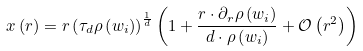<formula> <loc_0><loc_0><loc_500><loc_500>x \left ( r \right ) = r \left ( \tau _ { d } \rho \left ( w _ { i } \right ) \right ) ^ { \frac { 1 } { d } } \left ( 1 + \frac { r \cdot \partial _ { r } \rho \left ( w _ { i } \right ) } { d \cdot \rho \left ( w _ { i } \right ) } + \mathcal { O } \left ( r ^ { 2 } \right ) \right )</formula> 